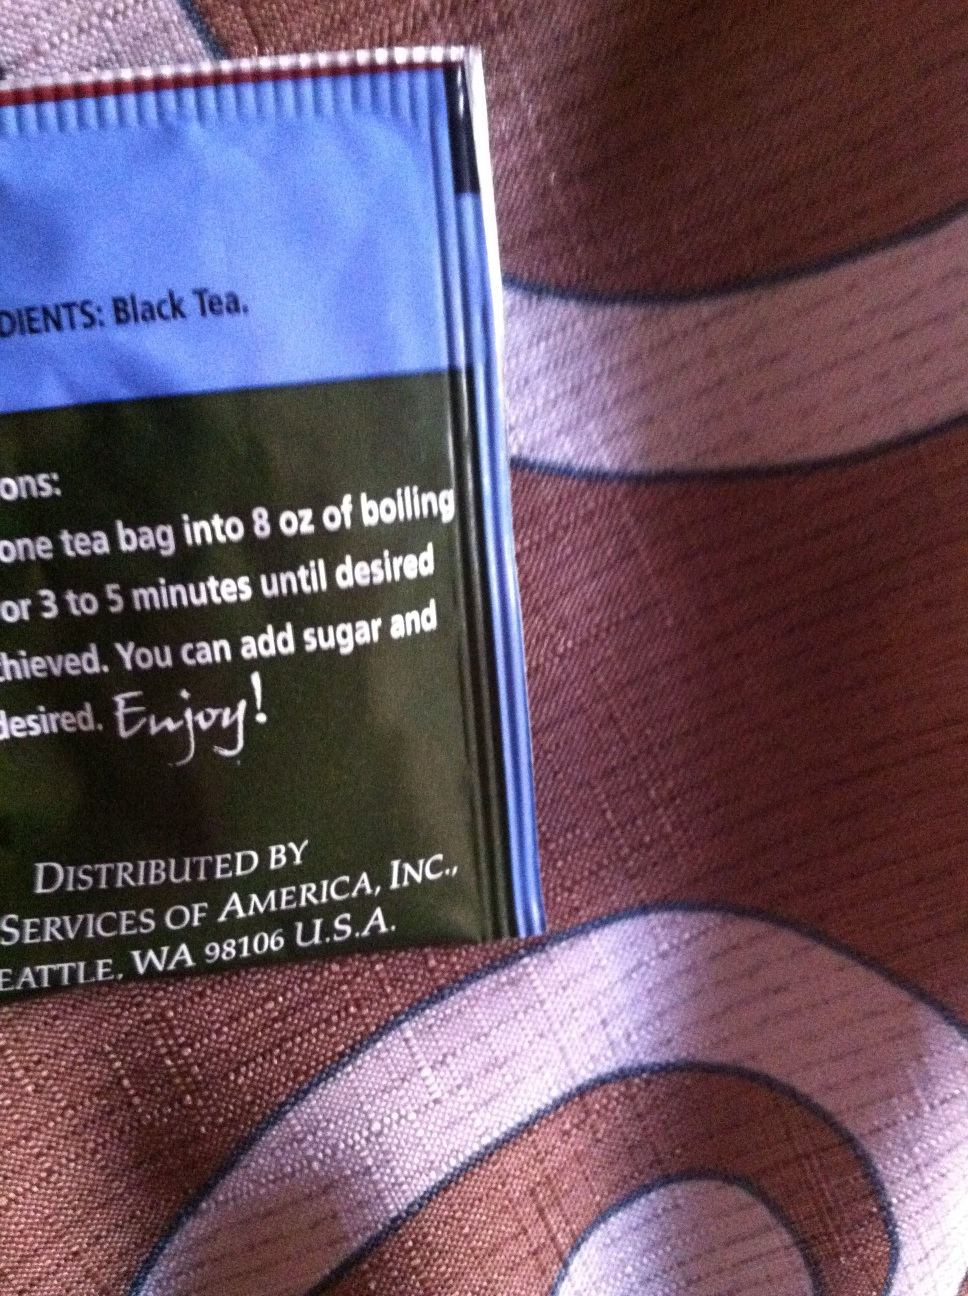What kind of tea is this? The tea shown in the image is black tea. You can steep one tea bag in 8 ounces of boiling water for 3 to 5 minutes to achieve the desired strength. It's a versatile tea that allows you to add sugar and other flavorings as you prefer. Enjoy your tea just how you like it! 